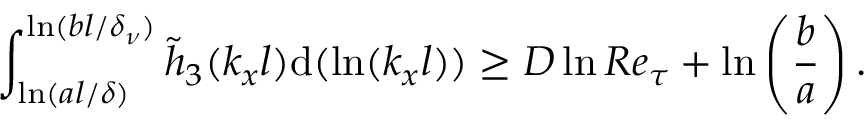<formula> <loc_0><loc_0><loc_500><loc_500>\int _ { \ln ( a l / \delta ) } ^ { \ln ( b l / \delta _ { \nu } ) } \tilde { h } _ { 3 } ( k _ { x } l ) d ( \ln ( k _ { x } l ) ) \geq D \ln R e _ { \tau } + \ln \left ( \frac { b } { a } \right ) .</formula> 